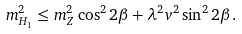<formula> <loc_0><loc_0><loc_500><loc_500>m _ { H _ { 1 } } ^ { 2 } \leq m _ { Z } ^ { 2 } \cos ^ { 2 } 2 \beta + \lambda ^ { 2 } v ^ { 2 } \sin ^ { 2 } 2 \beta .</formula> 